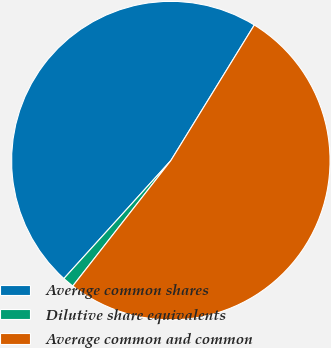Convert chart to OTSL. <chart><loc_0><loc_0><loc_500><loc_500><pie_chart><fcel>Average common shares<fcel>Dilutive share equivalents<fcel>Average common and common<nl><fcel>47.07%<fcel>1.16%<fcel>51.78%<nl></chart> 